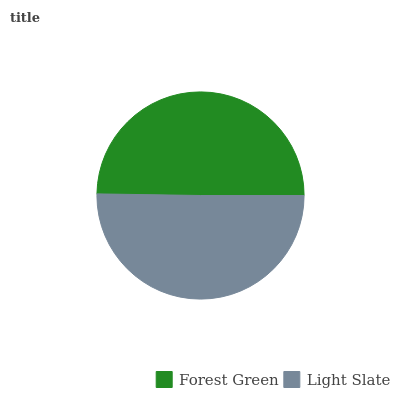Is Forest Green the minimum?
Answer yes or no. Yes. Is Light Slate the maximum?
Answer yes or no. Yes. Is Light Slate the minimum?
Answer yes or no. No. Is Light Slate greater than Forest Green?
Answer yes or no. Yes. Is Forest Green less than Light Slate?
Answer yes or no. Yes. Is Forest Green greater than Light Slate?
Answer yes or no. No. Is Light Slate less than Forest Green?
Answer yes or no. No. Is Light Slate the high median?
Answer yes or no. Yes. Is Forest Green the low median?
Answer yes or no. Yes. Is Forest Green the high median?
Answer yes or no. No. Is Light Slate the low median?
Answer yes or no. No. 